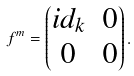Convert formula to latex. <formula><loc_0><loc_0><loc_500><loc_500>f ^ { m } = \begin{pmatrix} i d _ { k } & 0 \\ 0 & 0 \end{pmatrix} .</formula> 